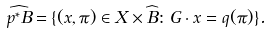Convert formula to latex. <formula><loc_0><loc_0><loc_500><loc_500>\widehat { p ^ { * } B } = \{ ( x , \pi ) \in X \times \widehat { B } \colon G \cdot x = q ( \pi ) \} .</formula> 